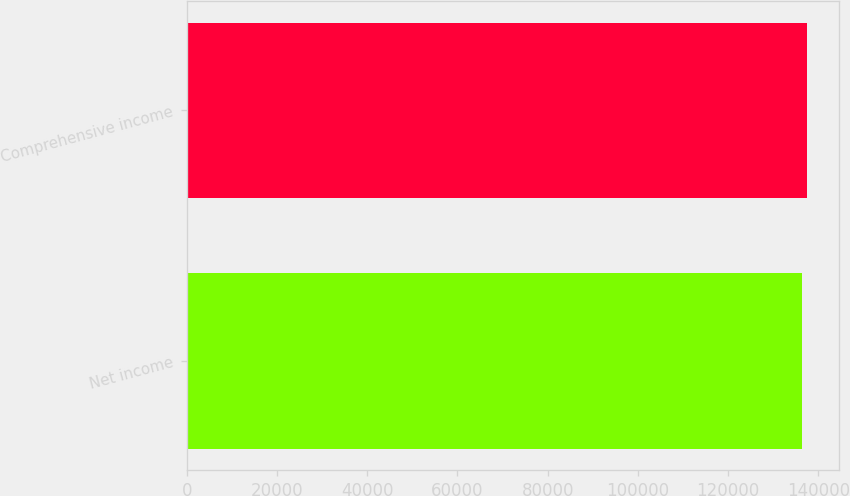Convert chart to OTSL. <chart><loc_0><loc_0><loc_500><loc_500><bar_chart><fcel>Net income<fcel>Comprehensive income<nl><fcel>136435<fcel>137621<nl></chart> 